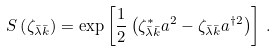Convert formula to latex. <formula><loc_0><loc_0><loc_500><loc_500>S \left ( \zeta _ { \bar { \lambda } \bar { k } } \right ) = \exp \left [ \frac { 1 } { 2 } \left ( \zeta _ { \bar { \lambda } \bar { k } } ^ { * } a ^ { 2 } - \zeta _ { \bar { \lambda } \bar { k } } a ^ { \dagger 2 } \right ) \right ] \, .</formula> 